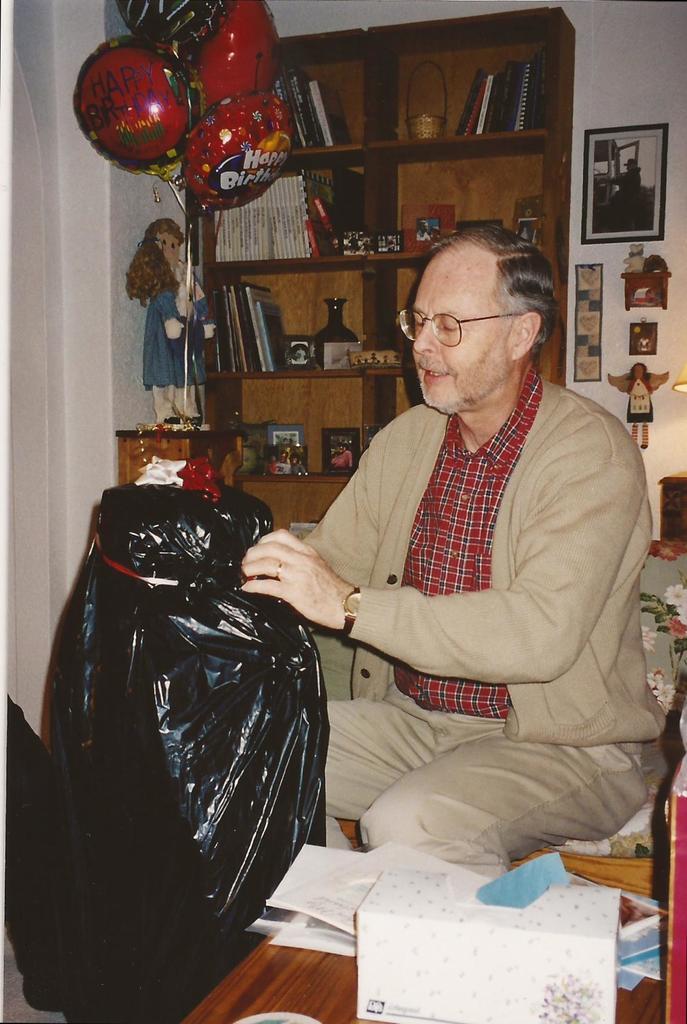Describe this image in one or two sentences. In the picture I can see a person wearing jacket and shirt is sitting on the chair and holding a black color object which is in front of him. Here I can see tissue and some papers are placed on the wooden surface. In the background, I can see some books are placed on the wooden cupboard, we can see balloons, toys and a photo frame fixed to the wall. 